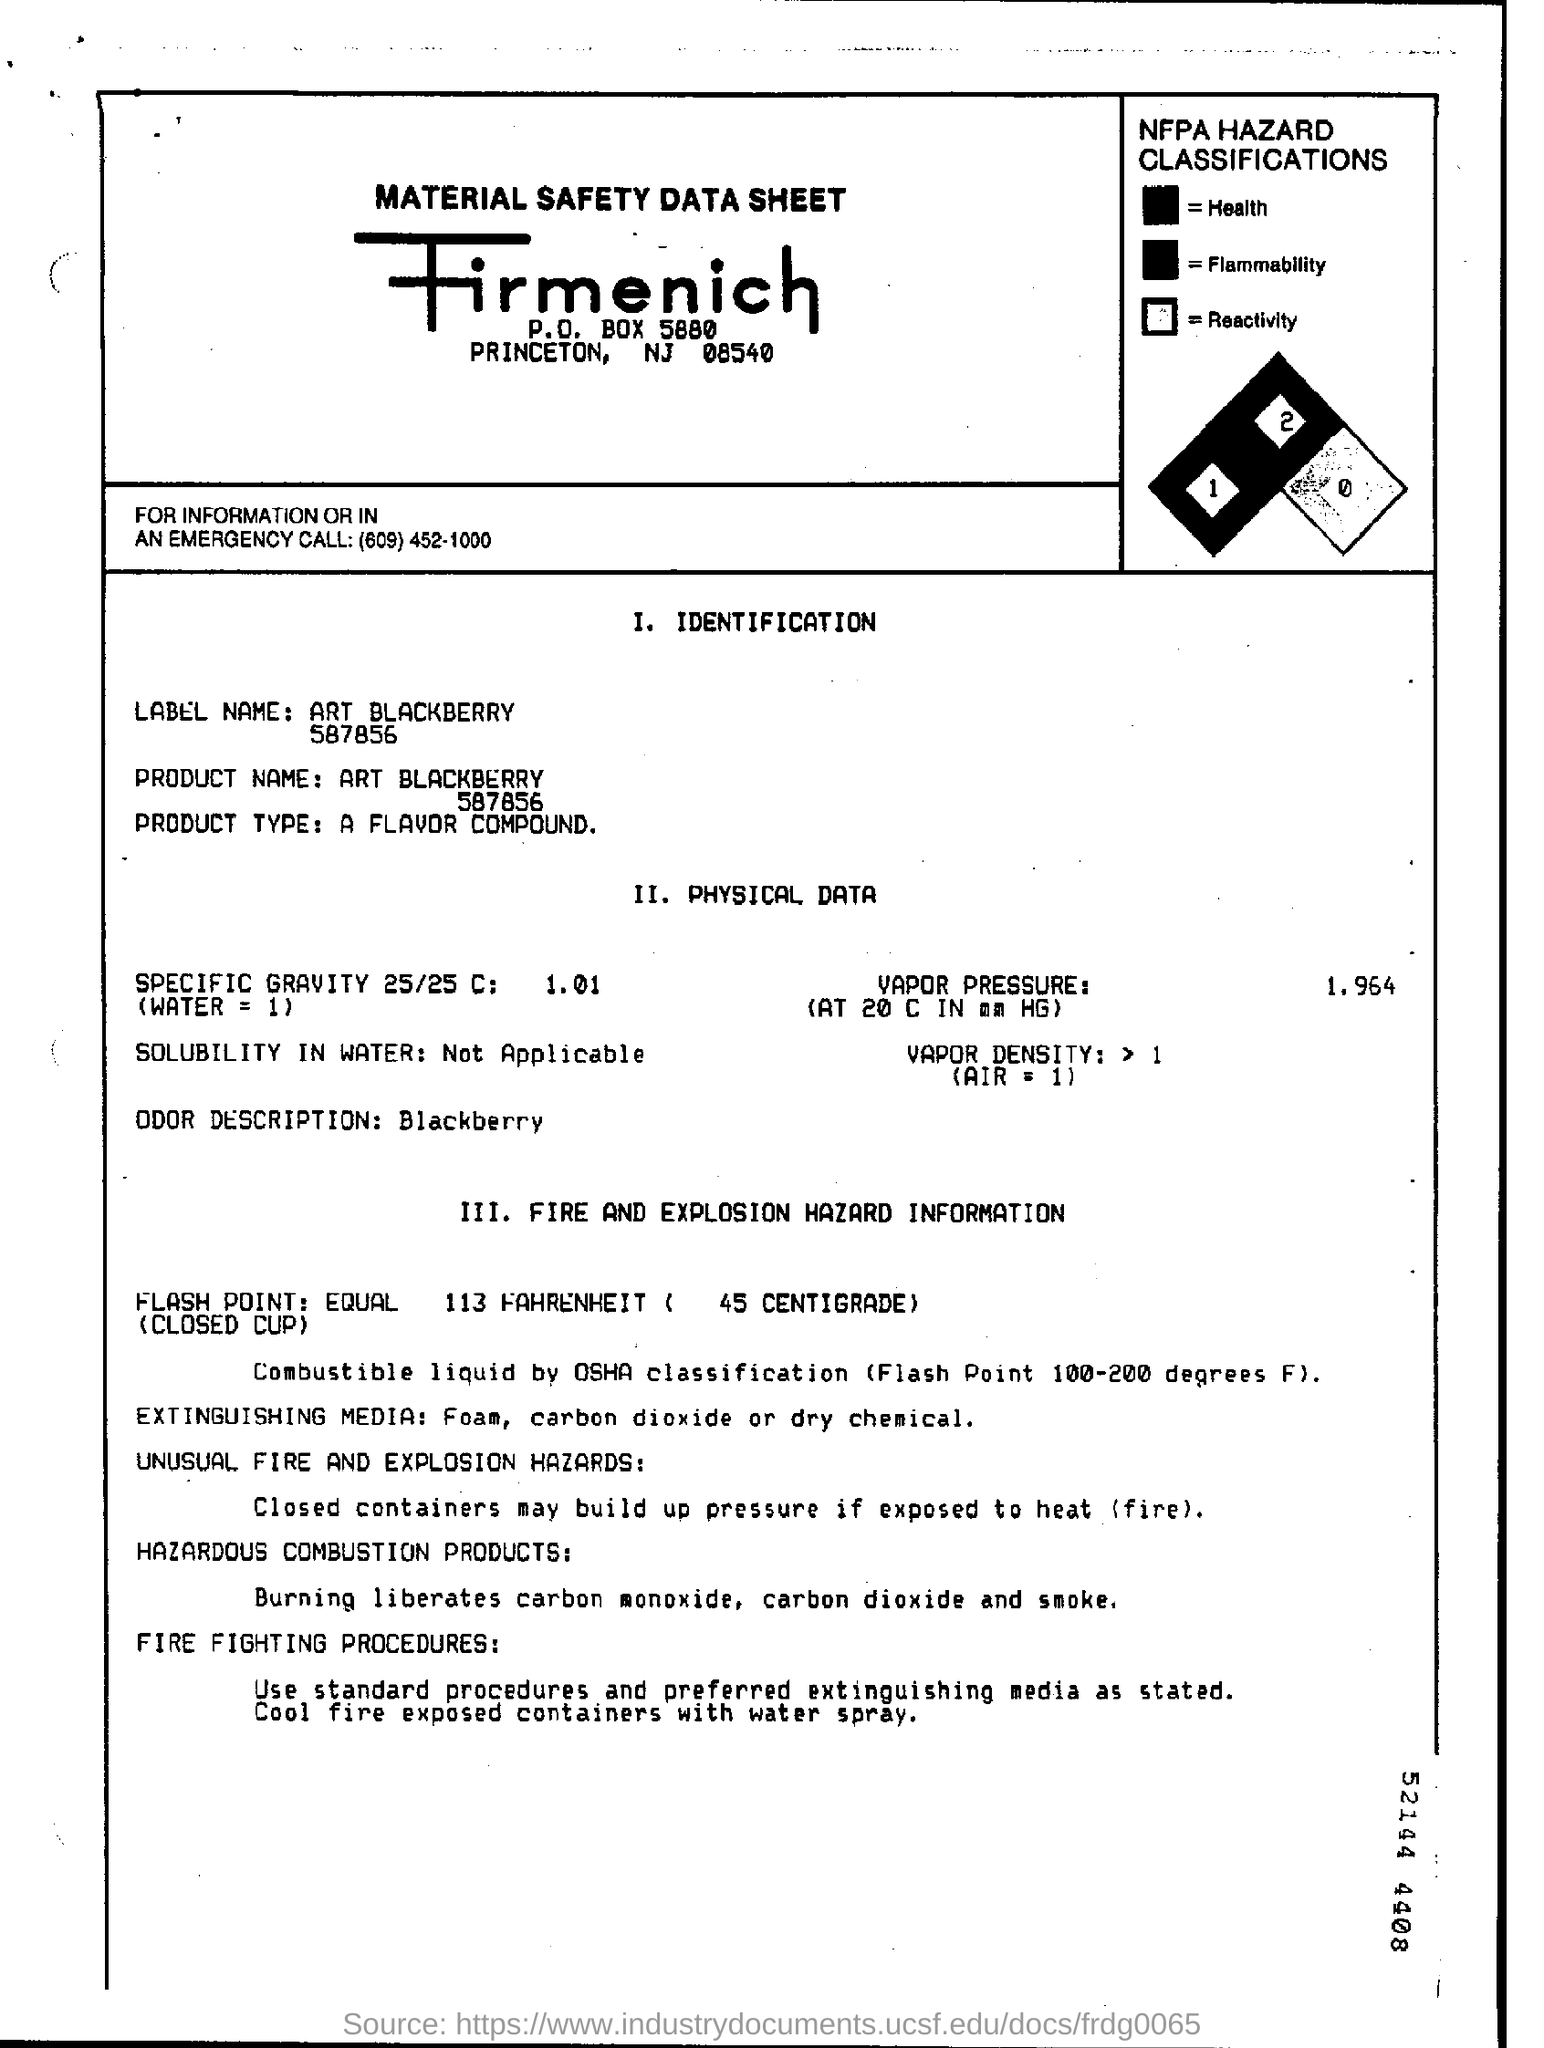List a handful of essential elements in this visual. What is vapor pressure? It is 1.964... 